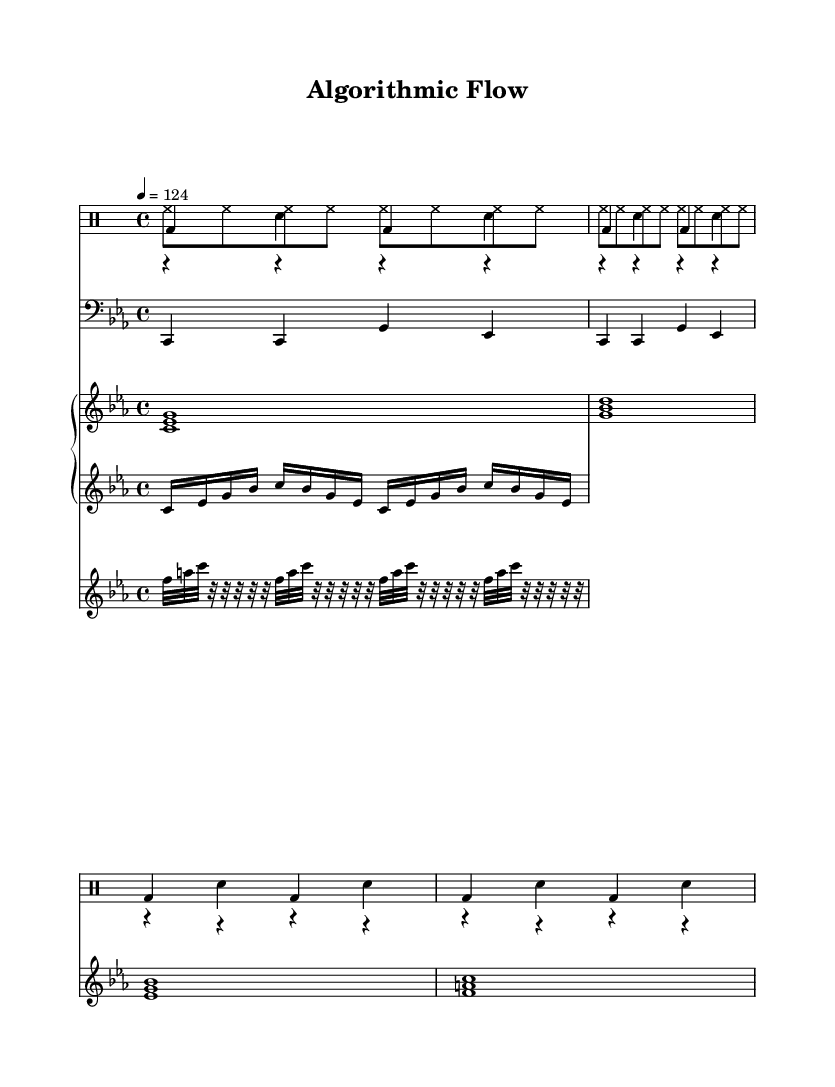What is the key signature of this music? The key signature is C minor, indicated by three flats in the key signature on the staff.
Answer: C minor What is the time signature of this music? The time signature is displayed at the beginning of the score and is written as 4/4, meaning there are four beats in a measure, and the quarter note gets one beat.
Answer: 4/4 What is the tempo marking? The tempo marking indicates the speed of the music as 124 beats per minute, which is noted in the score, providing a clear guideline for the performance speed.
Answer: 124 How many measures are there in the kick drum part? The kick drum part repeats a pattern four times, resulting in a total of four measures as indicated by the number of repetitions in the score.
Answer: 4 What kind of effect is represented by the last staff? The last staff showcases computer-like sound effects, a notable feature in minimal tech house music, which is characterized by subtle electronic sound elements.
Answer: computerFX What are the primary instruments used in this piece? The pieces are built primarily around drums, bass, synth pads, an arpeggiator, and sound effects, indicating a rich overlay of electronic and percussive sounds typical in house music.
Answer: drums, bass, synth pads, arpeggiator, sound effects How many distinct musical sections can be identified in the score? The score features four distinct sections, including the kick drum, hi-hat, snare, bass, synth pad, arpeggiator, and computer effects, each contributing to a layered musical texture.
Answer: 4 